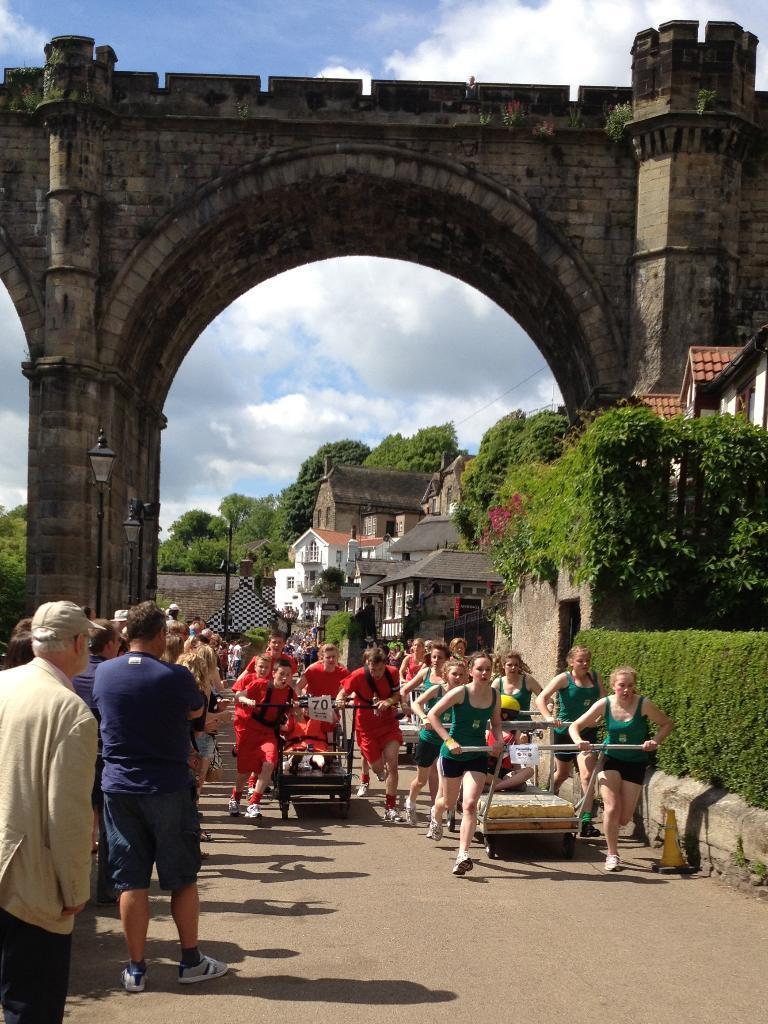Describe this image in one or two sentences. In this picture I can see group of people standing, there are few people holding carts, there is an arch, there are poles, lights, there are buildings, trees, and in the background there is the sky. 